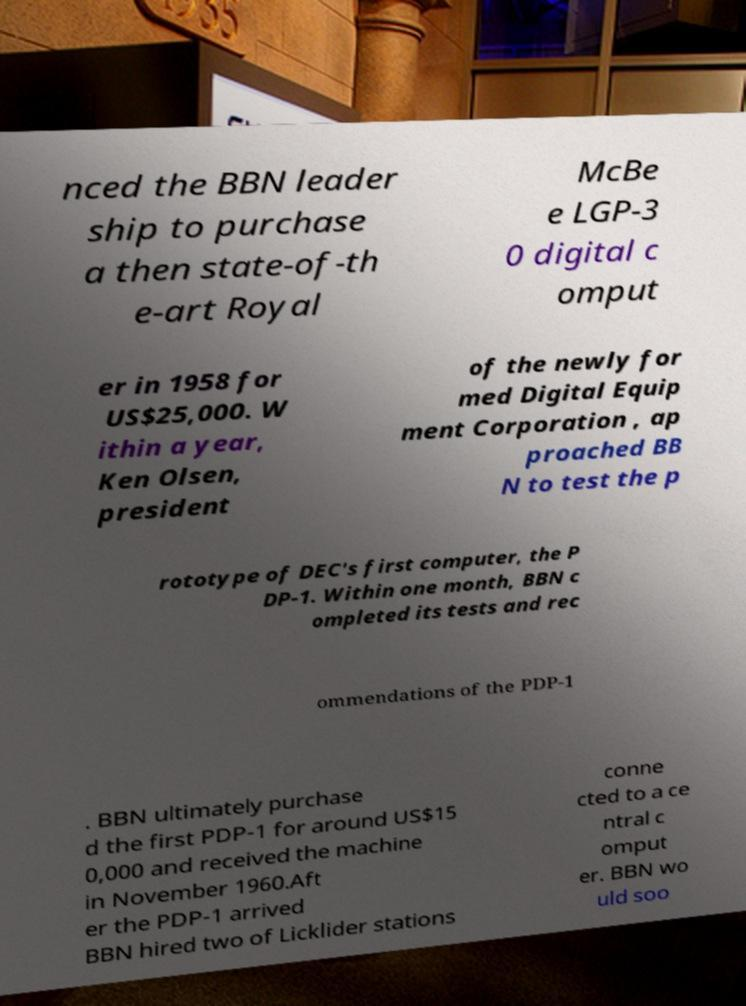For documentation purposes, I need the text within this image transcribed. Could you provide that? nced the BBN leader ship to purchase a then state-of-th e-art Royal McBe e LGP-3 0 digital c omput er in 1958 for US$25,000. W ithin a year, Ken Olsen, president of the newly for med Digital Equip ment Corporation , ap proached BB N to test the p rototype of DEC's first computer, the P DP-1. Within one month, BBN c ompleted its tests and rec ommendations of the PDP-1 . BBN ultimately purchase d the first PDP-1 for around US$15 0,000 and received the machine in November 1960.Aft er the PDP-1 arrived BBN hired two of Licklider stations conne cted to a ce ntral c omput er. BBN wo uld soo 